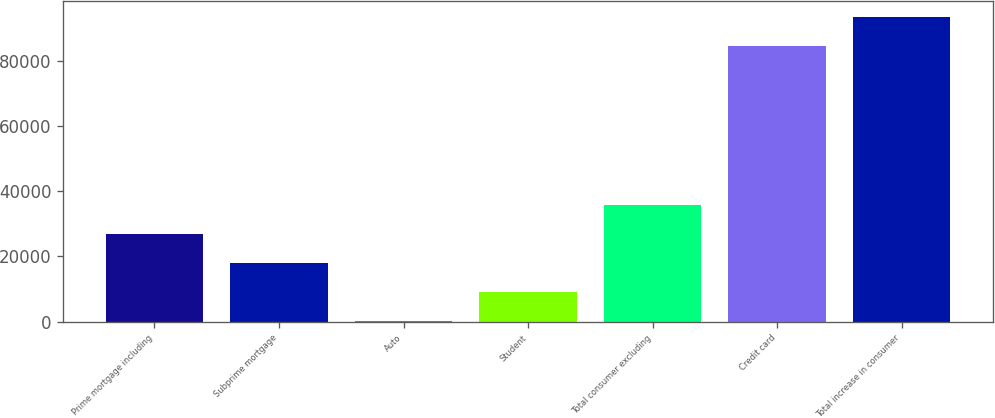<chart> <loc_0><loc_0><loc_500><loc_500><bar_chart><fcel>Prime mortgage including<fcel>Subprime mortgage<fcel>Auto<fcel>Student<fcel>Total consumer excluding<fcel>Credit card<fcel>Total increase in consumer<nl><fcel>27004.1<fcel>18075.4<fcel>218<fcel>9146.7<fcel>35932.8<fcel>84663<fcel>93591.7<nl></chart> 